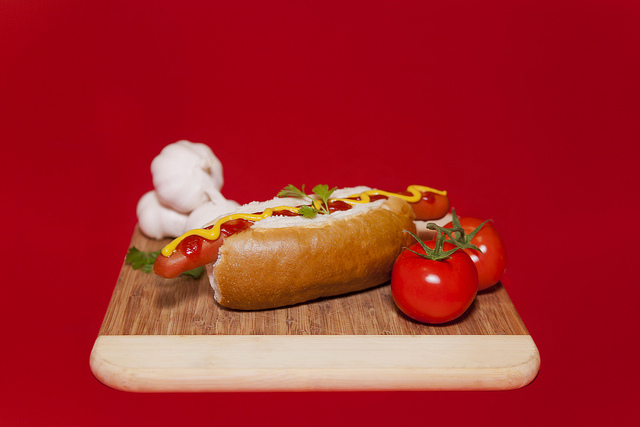What kind of garnish is on the entree? The garnish on the entree appears to be fresh parsley, adding a touch of green and a hint of flavor. 